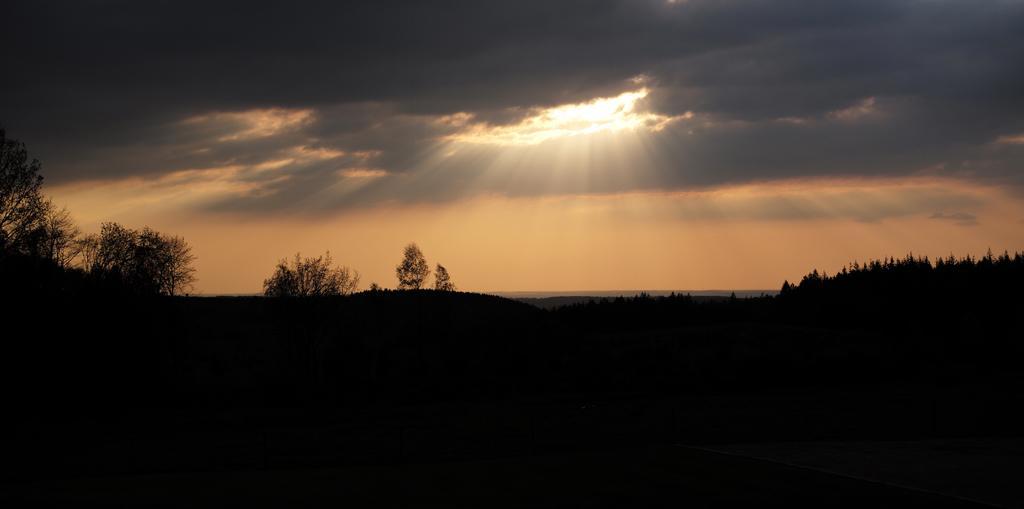Can you describe this image briefly? At the bottom the image is not visible but we can see trees and in the background we can see clouds in the sky. 